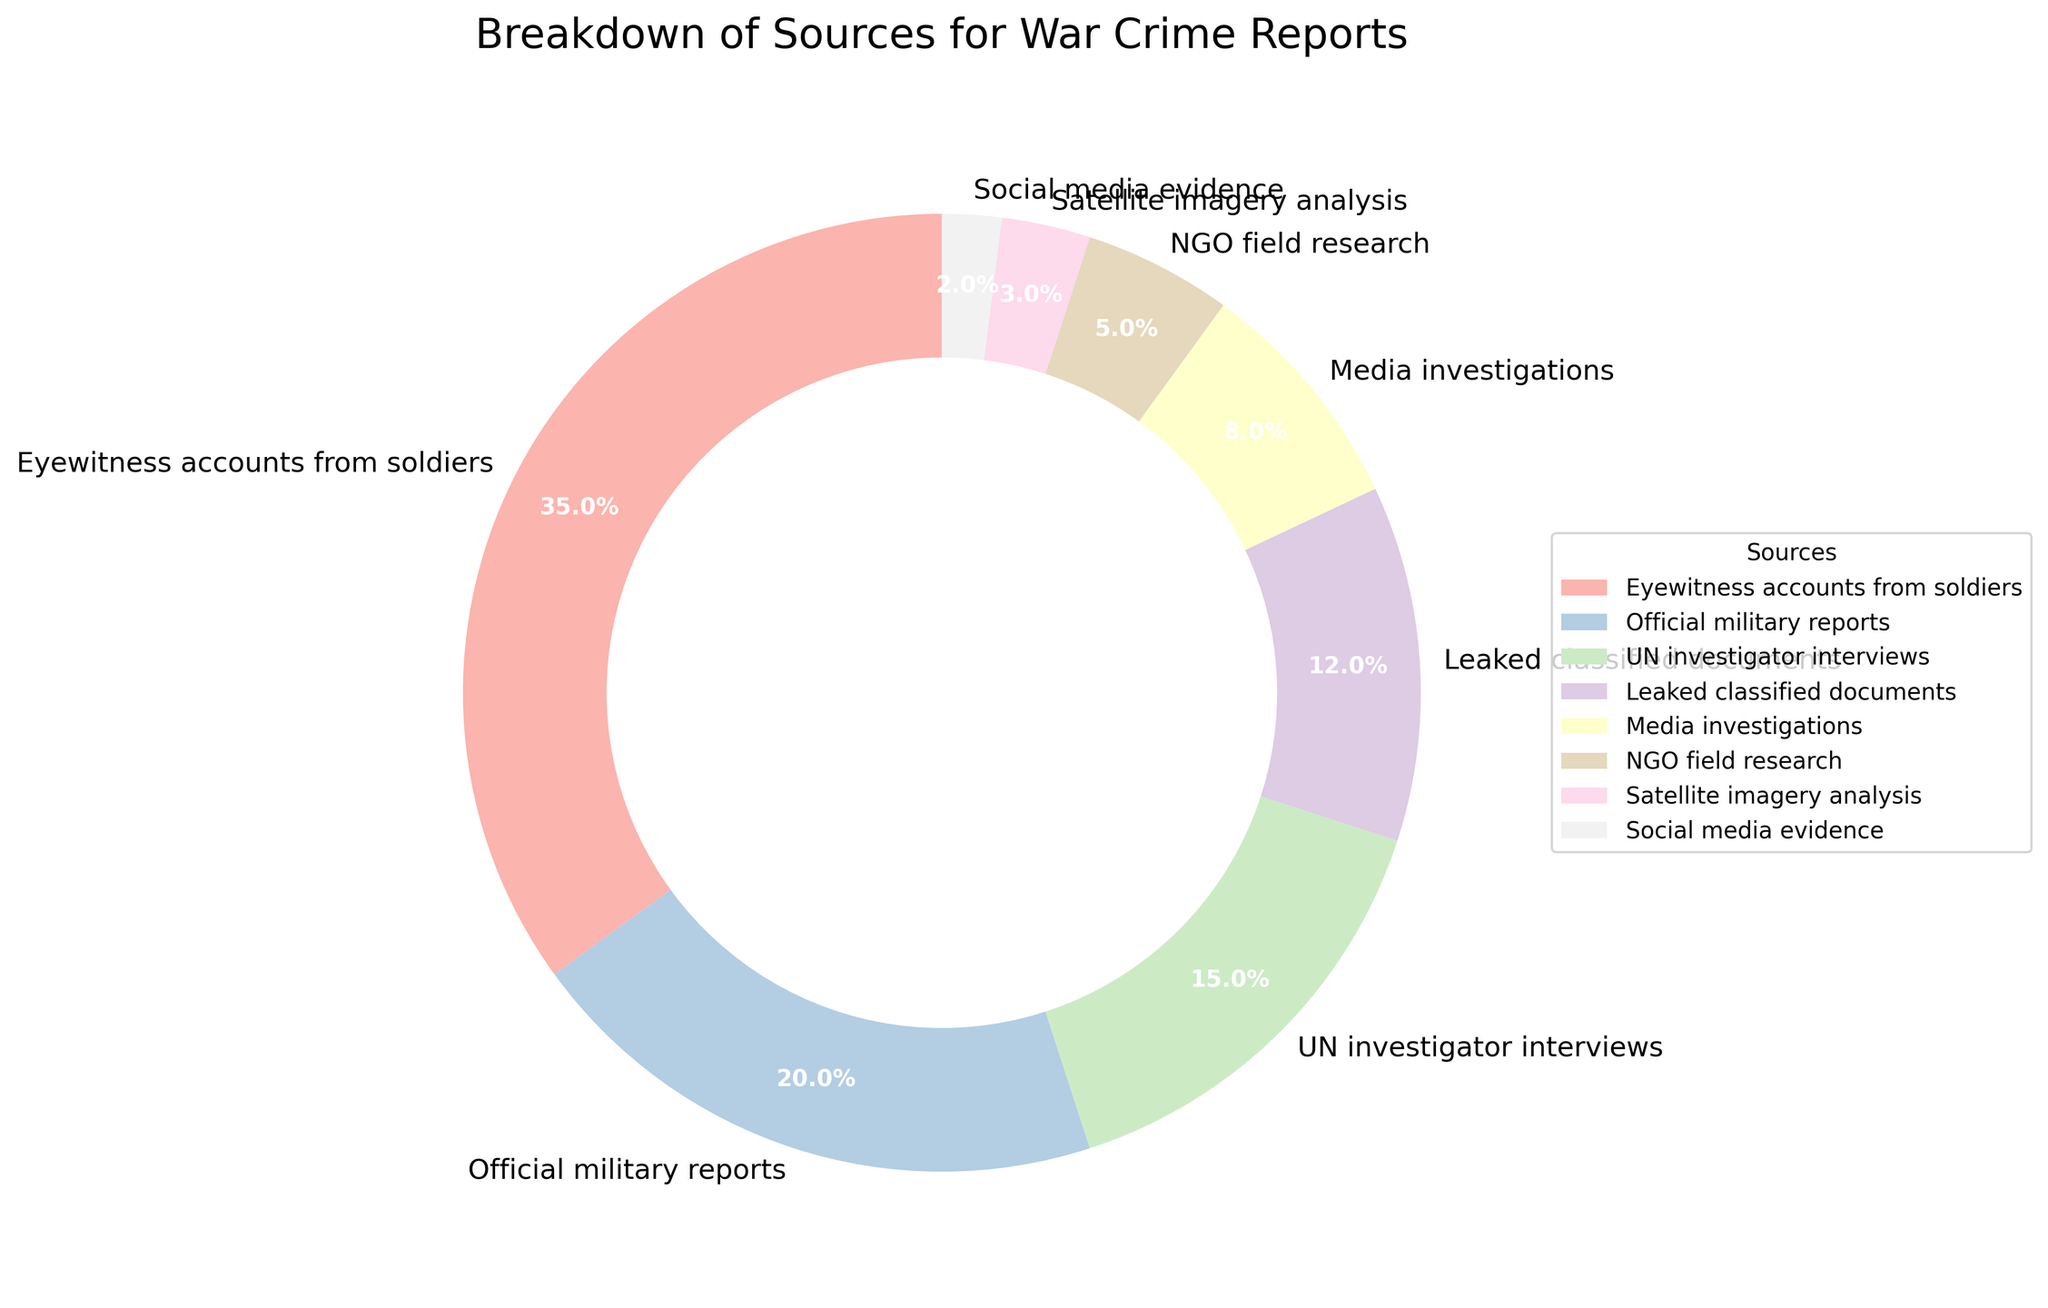Which source contributes the largest percentage to war crime reports? Look for the source with the highest percentage in the pie chart to identify which contributes the most. "Eyewitness accounts from soldiers" has the largest slice at 35%.
Answer: Eyewitness accounts from soldiers What is the total percentage contribution of UN investigator interviews and NGO field research? Sum the percentages of "UN investigator interviews" and "NGO field research". 15% + 5% equals 20%.
Answer: 20% Which is greater, the percentage of official military reports or media investigations? Compare the percentages of "Official military reports" and "Media investigations". Official military reports at 20% are greater than media investigations at 8%.
Answer: Official military reports Which sources have a combined total of greater than 50%? Identify sources whose individual percentages total more than 50%. "Eyewitness accounts from soldiers" (35%), "Official military reports" (20%) add up to 55%.
Answer: Eyewitness accounts from soldiers and Official military reports By how much does the percentage of eyewitness accounts from soldiers exceed that of leaked classified documents? Subtract the percentage of "Leaked classified documents" (12%) from "Eyewitness accounts from soldiers" (35%). 35% - 12% equals 23%.
Answer: 23% What is the average percentage contribution of satellite imagery analysis and social media evidence? Calculate the average of "Satellite imagery analysis" (3%) and "Social media evidence" (2%). (3% + 2%) / 2 equals 2.5%.
Answer: 2.5% Which source is the smallest contributor to war crime reports? Identify the source with the smallest percentage in the pie chart. "Social media evidence" has the smallest slice at 2%.
Answer: Social media evidence Combine the contributions of media investigations and official military reports. Is the total percentage higher than that of eyewitness accounts from soldiers? Sum the percentages of "Media investigations" (8%) and "Official military reports" (20%), compare the total (28%) to "Eyewitness accounts from soldiers" (35%). 28% is less than 35%.
Answer: No 